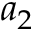Convert formula to latex. <formula><loc_0><loc_0><loc_500><loc_500>a _ { 2 }</formula> 